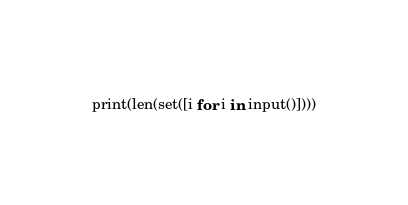<code> <loc_0><loc_0><loc_500><loc_500><_Python_>print(len(set([i for i in input()])))</code> 